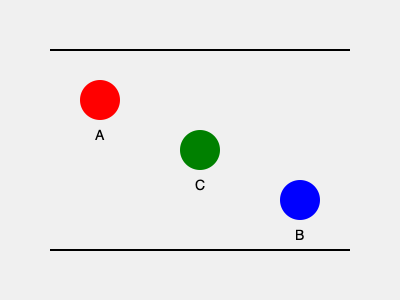In this storyboard representation of a scene, three actors (A, B, and C) are positioned as shown. If the distance between the top and bottom of the frame represents 20 feet, what is the approximate distance between actors A and B in feet? To solve this problem, we need to follow these steps:

1. Determine the scale of the storyboard:
   - The vertical distance of the frame represents 20 feet.
   - In the SVG, this distance is 200 pixels (250 - 50).
   - So, the scale is 20 feet / 200 pixels = 0.1 feet/pixel.

2. Calculate the horizontal and vertical distances between A and B:
   - Horizontal distance: 300 - 100 = 200 pixels
   - Vertical distance: 200 - 100 = 100 pixels

3. Use the Pythagorean theorem to calculate the direct distance:
   $$ d = \sqrt{(200\text{ px})^2 + (100\text{ px})^2} $$
   $$ d = \sqrt{40000\text{ px}^2 + 10000\text{ px}^2} $$
   $$ d = \sqrt{50000\text{ px}^2} $$
   $$ d \approx 223.6\text{ px} $$

4. Convert the pixel distance to feet:
   $$ 223.6\text{ px} \times 0.1\text{ feet/px} \approx 22.36\text{ feet} $$

Therefore, the approximate distance between actors A and B is 22.36 feet.
Answer: 22.36 feet 